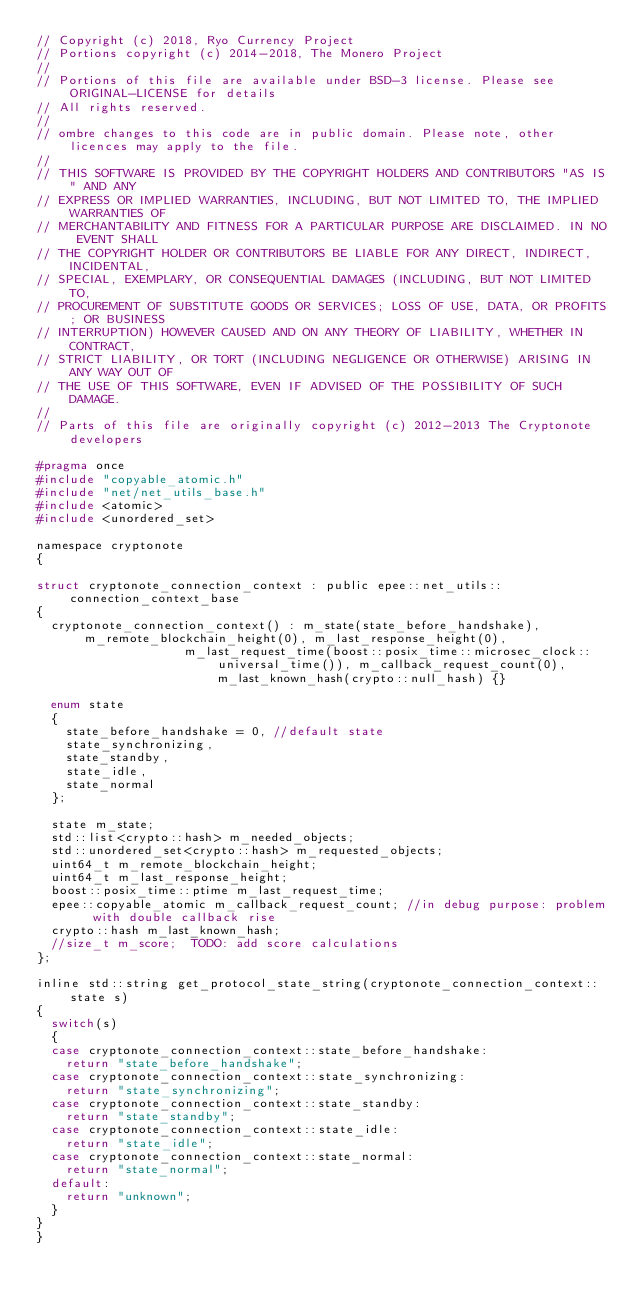Convert code to text. <code><loc_0><loc_0><loc_500><loc_500><_C_>// Copyright (c) 2018, Ryo Currency Project
// Portions copyright (c) 2014-2018, The Monero Project
//
// Portions of this file are available under BSD-3 license. Please see ORIGINAL-LICENSE for details
// All rights reserved.
//
// ombre changes to this code are in public domain. Please note, other licences may apply to the file.
//
// THIS SOFTWARE IS PROVIDED BY THE COPYRIGHT HOLDERS AND CONTRIBUTORS "AS IS" AND ANY
// EXPRESS OR IMPLIED WARRANTIES, INCLUDING, BUT NOT LIMITED TO, THE IMPLIED WARRANTIES OF
// MERCHANTABILITY AND FITNESS FOR A PARTICULAR PURPOSE ARE DISCLAIMED. IN NO EVENT SHALL
// THE COPYRIGHT HOLDER OR CONTRIBUTORS BE LIABLE FOR ANY DIRECT, INDIRECT, INCIDENTAL,
// SPECIAL, EXEMPLARY, OR CONSEQUENTIAL DAMAGES (INCLUDING, BUT NOT LIMITED TO,
// PROCUREMENT OF SUBSTITUTE GOODS OR SERVICES; LOSS OF USE, DATA, OR PROFITS; OR BUSINESS
// INTERRUPTION) HOWEVER CAUSED AND ON ANY THEORY OF LIABILITY, WHETHER IN CONTRACT,
// STRICT LIABILITY, OR TORT (INCLUDING NEGLIGENCE OR OTHERWISE) ARISING IN ANY WAY OUT OF
// THE USE OF THIS SOFTWARE, EVEN IF ADVISED OF THE POSSIBILITY OF SUCH DAMAGE.
//
// Parts of this file are originally copyright (c) 2012-2013 The Cryptonote developers

#pragma once
#include "copyable_atomic.h"
#include "net/net_utils_base.h"
#include <atomic>
#include <unordered_set>

namespace cryptonote
{

struct cryptonote_connection_context : public epee::net_utils::connection_context_base
{
	cryptonote_connection_context() : m_state(state_before_handshake), m_remote_blockchain_height(0), m_last_response_height(0),
									  m_last_request_time(boost::posix_time::microsec_clock::universal_time()), m_callback_request_count(0), m_last_known_hash(crypto::null_hash) {}

	enum state
	{
		state_before_handshake = 0, //default state
		state_synchronizing,
		state_standby,
		state_idle,
		state_normal
	};

	state m_state;
	std::list<crypto::hash> m_needed_objects;
	std::unordered_set<crypto::hash> m_requested_objects;
	uint64_t m_remote_blockchain_height;
	uint64_t m_last_response_height;
	boost::posix_time::ptime m_last_request_time;
	epee::copyable_atomic m_callback_request_count; //in debug purpose: problem with double callback rise
	crypto::hash m_last_known_hash;
	//size_t m_score;  TODO: add score calculations
};

inline std::string get_protocol_state_string(cryptonote_connection_context::state s)
{
	switch(s)
	{
	case cryptonote_connection_context::state_before_handshake:
		return "state_before_handshake";
	case cryptonote_connection_context::state_synchronizing:
		return "state_synchronizing";
	case cryptonote_connection_context::state_standby:
		return "state_standby";
	case cryptonote_connection_context::state_idle:
		return "state_idle";
	case cryptonote_connection_context::state_normal:
		return "state_normal";
	default:
		return "unknown";
	}
}
}
</code> 